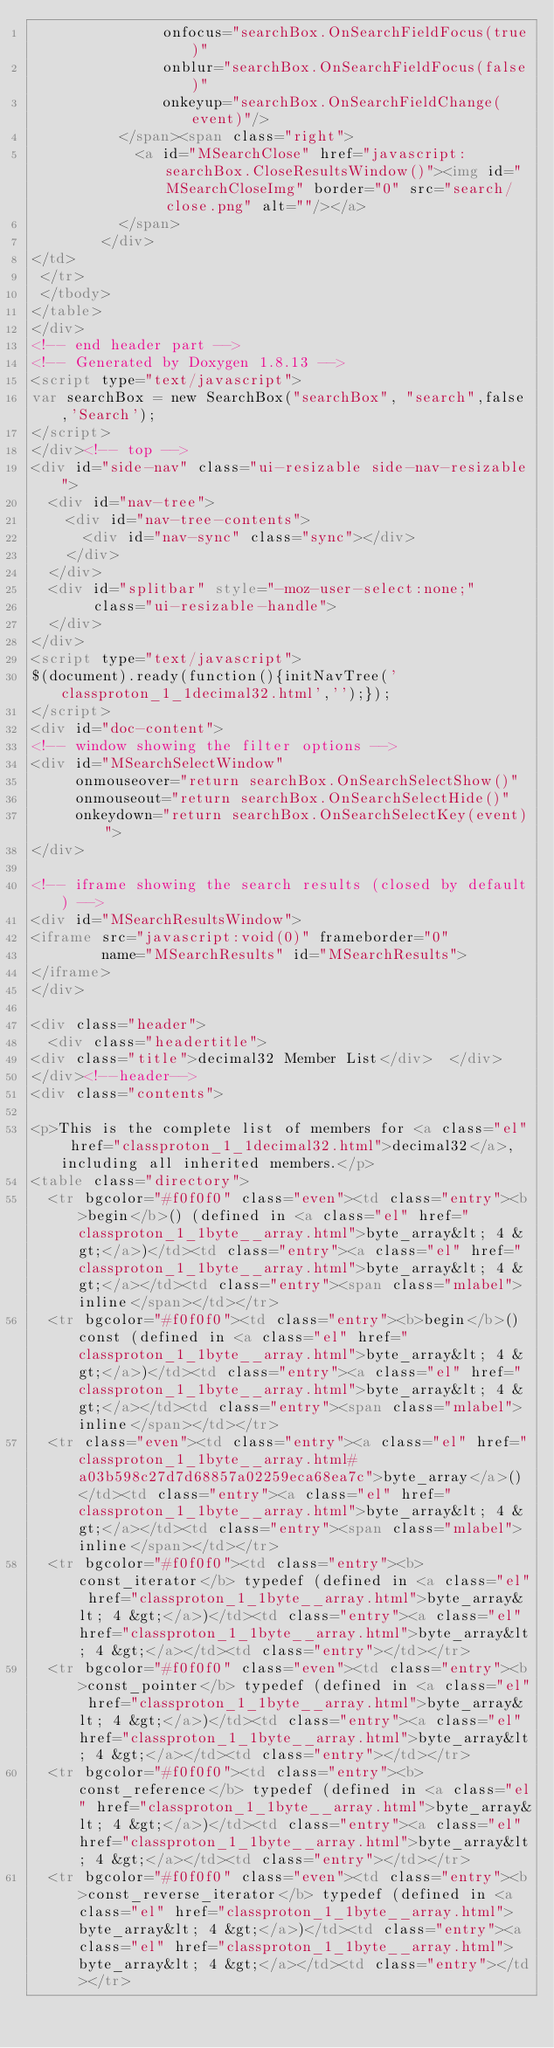<code> <loc_0><loc_0><loc_500><loc_500><_HTML_>               onfocus="searchBox.OnSearchFieldFocus(true)" 
               onblur="searchBox.OnSearchFieldFocus(false)" 
               onkeyup="searchBox.OnSearchFieldChange(event)"/>
          </span><span class="right">
            <a id="MSearchClose" href="javascript:searchBox.CloseResultsWindow()"><img id="MSearchCloseImg" border="0" src="search/close.png" alt=""/></a>
          </span>
        </div>
</td>
 </tr>
 </tbody>
</table>
</div>
<!-- end header part -->
<!-- Generated by Doxygen 1.8.13 -->
<script type="text/javascript">
var searchBox = new SearchBox("searchBox", "search",false,'Search');
</script>
</div><!-- top -->
<div id="side-nav" class="ui-resizable side-nav-resizable">
  <div id="nav-tree">
    <div id="nav-tree-contents">
      <div id="nav-sync" class="sync"></div>
    </div>
  </div>
  <div id="splitbar" style="-moz-user-select:none;" 
       class="ui-resizable-handle">
  </div>
</div>
<script type="text/javascript">
$(document).ready(function(){initNavTree('classproton_1_1decimal32.html','');});
</script>
<div id="doc-content">
<!-- window showing the filter options -->
<div id="MSearchSelectWindow"
     onmouseover="return searchBox.OnSearchSelectShow()"
     onmouseout="return searchBox.OnSearchSelectHide()"
     onkeydown="return searchBox.OnSearchSelectKey(event)">
</div>

<!-- iframe showing the search results (closed by default) -->
<div id="MSearchResultsWindow">
<iframe src="javascript:void(0)" frameborder="0" 
        name="MSearchResults" id="MSearchResults">
</iframe>
</div>

<div class="header">
  <div class="headertitle">
<div class="title">decimal32 Member List</div>  </div>
</div><!--header-->
<div class="contents">

<p>This is the complete list of members for <a class="el" href="classproton_1_1decimal32.html">decimal32</a>, including all inherited members.</p>
<table class="directory">
  <tr bgcolor="#f0f0f0" class="even"><td class="entry"><b>begin</b>() (defined in <a class="el" href="classproton_1_1byte__array.html">byte_array&lt; 4 &gt;</a>)</td><td class="entry"><a class="el" href="classproton_1_1byte__array.html">byte_array&lt; 4 &gt;</a></td><td class="entry"><span class="mlabel">inline</span></td></tr>
  <tr bgcolor="#f0f0f0"><td class="entry"><b>begin</b>() const (defined in <a class="el" href="classproton_1_1byte__array.html">byte_array&lt; 4 &gt;</a>)</td><td class="entry"><a class="el" href="classproton_1_1byte__array.html">byte_array&lt; 4 &gt;</a></td><td class="entry"><span class="mlabel">inline</span></td></tr>
  <tr class="even"><td class="entry"><a class="el" href="classproton_1_1byte__array.html#a03b598c27d7d68857a02259eca68ea7c">byte_array</a>()</td><td class="entry"><a class="el" href="classproton_1_1byte__array.html">byte_array&lt; 4 &gt;</a></td><td class="entry"><span class="mlabel">inline</span></td></tr>
  <tr bgcolor="#f0f0f0"><td class="entry"><b>const_iterator</b> typedef (defined in <a class="el" href="classproton_1_1byte__array.html">byte_array&lt; 4 &gt;</a>)</td><td class="entry"><a class="el" href="classproton_1_1byte__array.html">byte_array&lt; 4 &gt;</a></td><td class="entry"></td></tr>
  <tr bgcolor="#f0f0f0" class="even"><td class="entry"><b>const_pointer</b> typedef (defined in <a class="el" href="classproton_1_1byte__array.html">byte_array&lt; 4 &gt;</a>)</td><td class="entry"><a class="el" href="classproton_1_1byte__array.html">byte_array&lt; 4 &gt;</a></td><td class="entry"></td></tr>
  <tr bgcolor="#f0f0f0"><td class="entry"><b>const_reference</b> typedef (defined in <a class="el" href="classproton_1_1byte__array.html">byte_array&lt; 4 &gt;</a>)</td><td class="entry"><a class="el" href="classproton_1_1byte__array.html">byte_array&lt; 4 &gt;</a></td><td class="entry"></td></tr>
  <tr bgcolor="#f0f0f0" class="even"><td class="entry"><b>const_reverse_iterator</b> typedef (defined in <a class="el" href="classproton_1_1byte__array.html">byte_array&lt; 4 &gt;</a>)</td><td class="entry"><a class="el" href="classproton_1_1byte__array.html">byte_array&lt; 4 &gt;</a></td><td class="entry"></td></tr></code> 